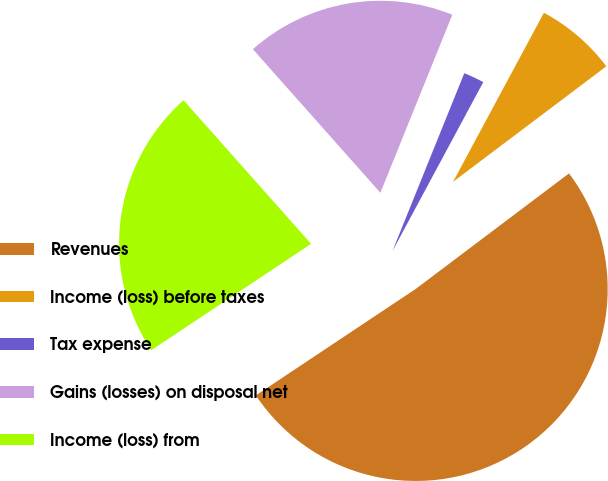<chart> <loc_0><loc_0><loc_500><loc_500><pie_chart><fcel>Revenues<fcel>Income (loss) before taxes<fcel>Tax expense<fcel>Gains (losses) on disposal net<fcel>Income (loss) from<nl><fcel>50.93%<fcel>6.87%<fcel>1.74%<fcel>17.67%<fcel>22.79%<nl></chart> 